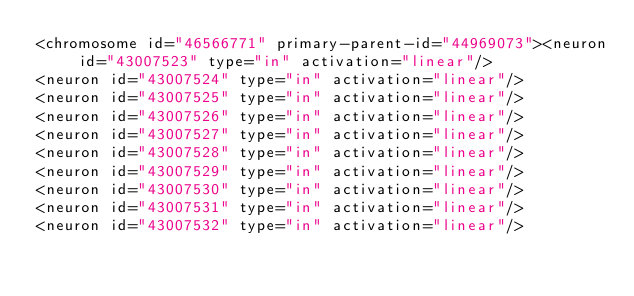Convert code to text. <code><loc_0><loc_0><loc_500><loc_500><_XML_><chromosome id="46566771" primary-parent-id="44969073"><neuron id="43007523" type="in" activation="linear"/>
<neuron id="43007524" type="in" activation="linear"/>
<neuron id="43007525" type="in" activation="linear"/>
<neuron id="43007526" type="in" activation="linear"/>
<neuron id="43007527" type="in" activation="linear"/>
<neuron id="43007528" type="in" activation="linear"/>
<neuron id="43007529" type="in" activation="linear"/>
<neuron id="43007530" type="in" activation="linear"/>
<neuron id="43007531" type="in" activation="linear"/>
<neuron id="43007532" type="in" activation="linear"/></code> 